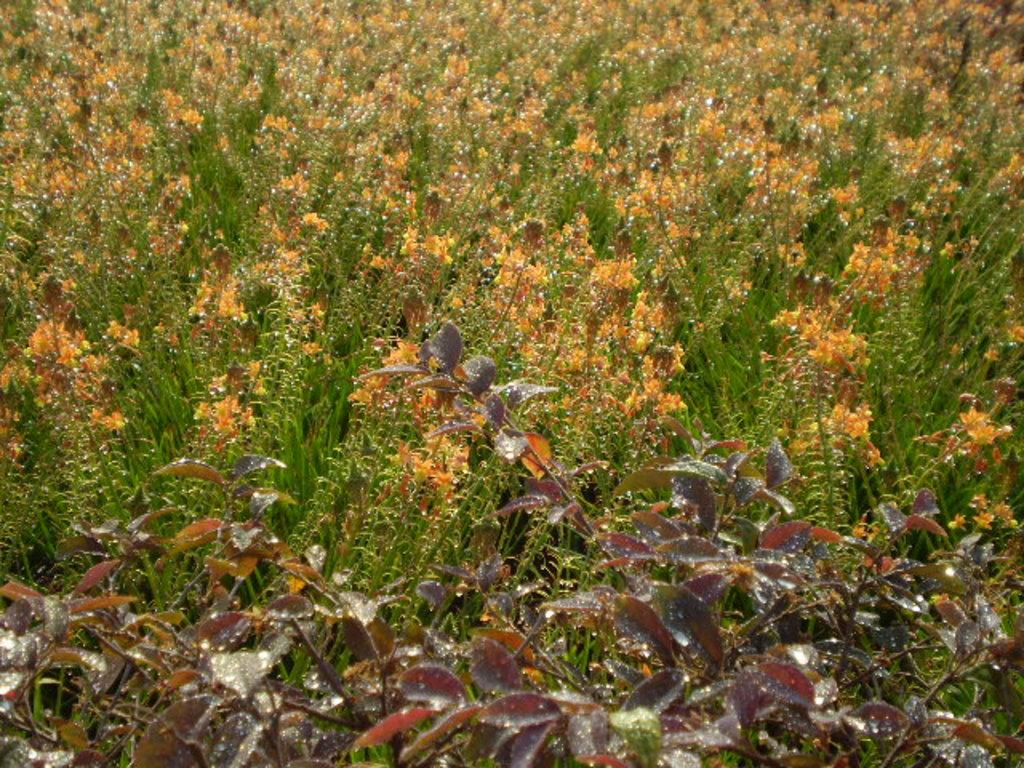What type of plant can be seen in the image? There is a crop in the image. What part of the plant is visible in the image? Leaves are visible in the image. Are there any additional features of the plant visible in the image? Yes, there are flowers visible in the image. What type of calculator can be seen in the image? There is no calculator present in the image. How does the crop attract attention in the image? The crop itself does not attract attention in the image, as it is a static subject. However, the presence of leaves and flowers may draw attention to the plant. 